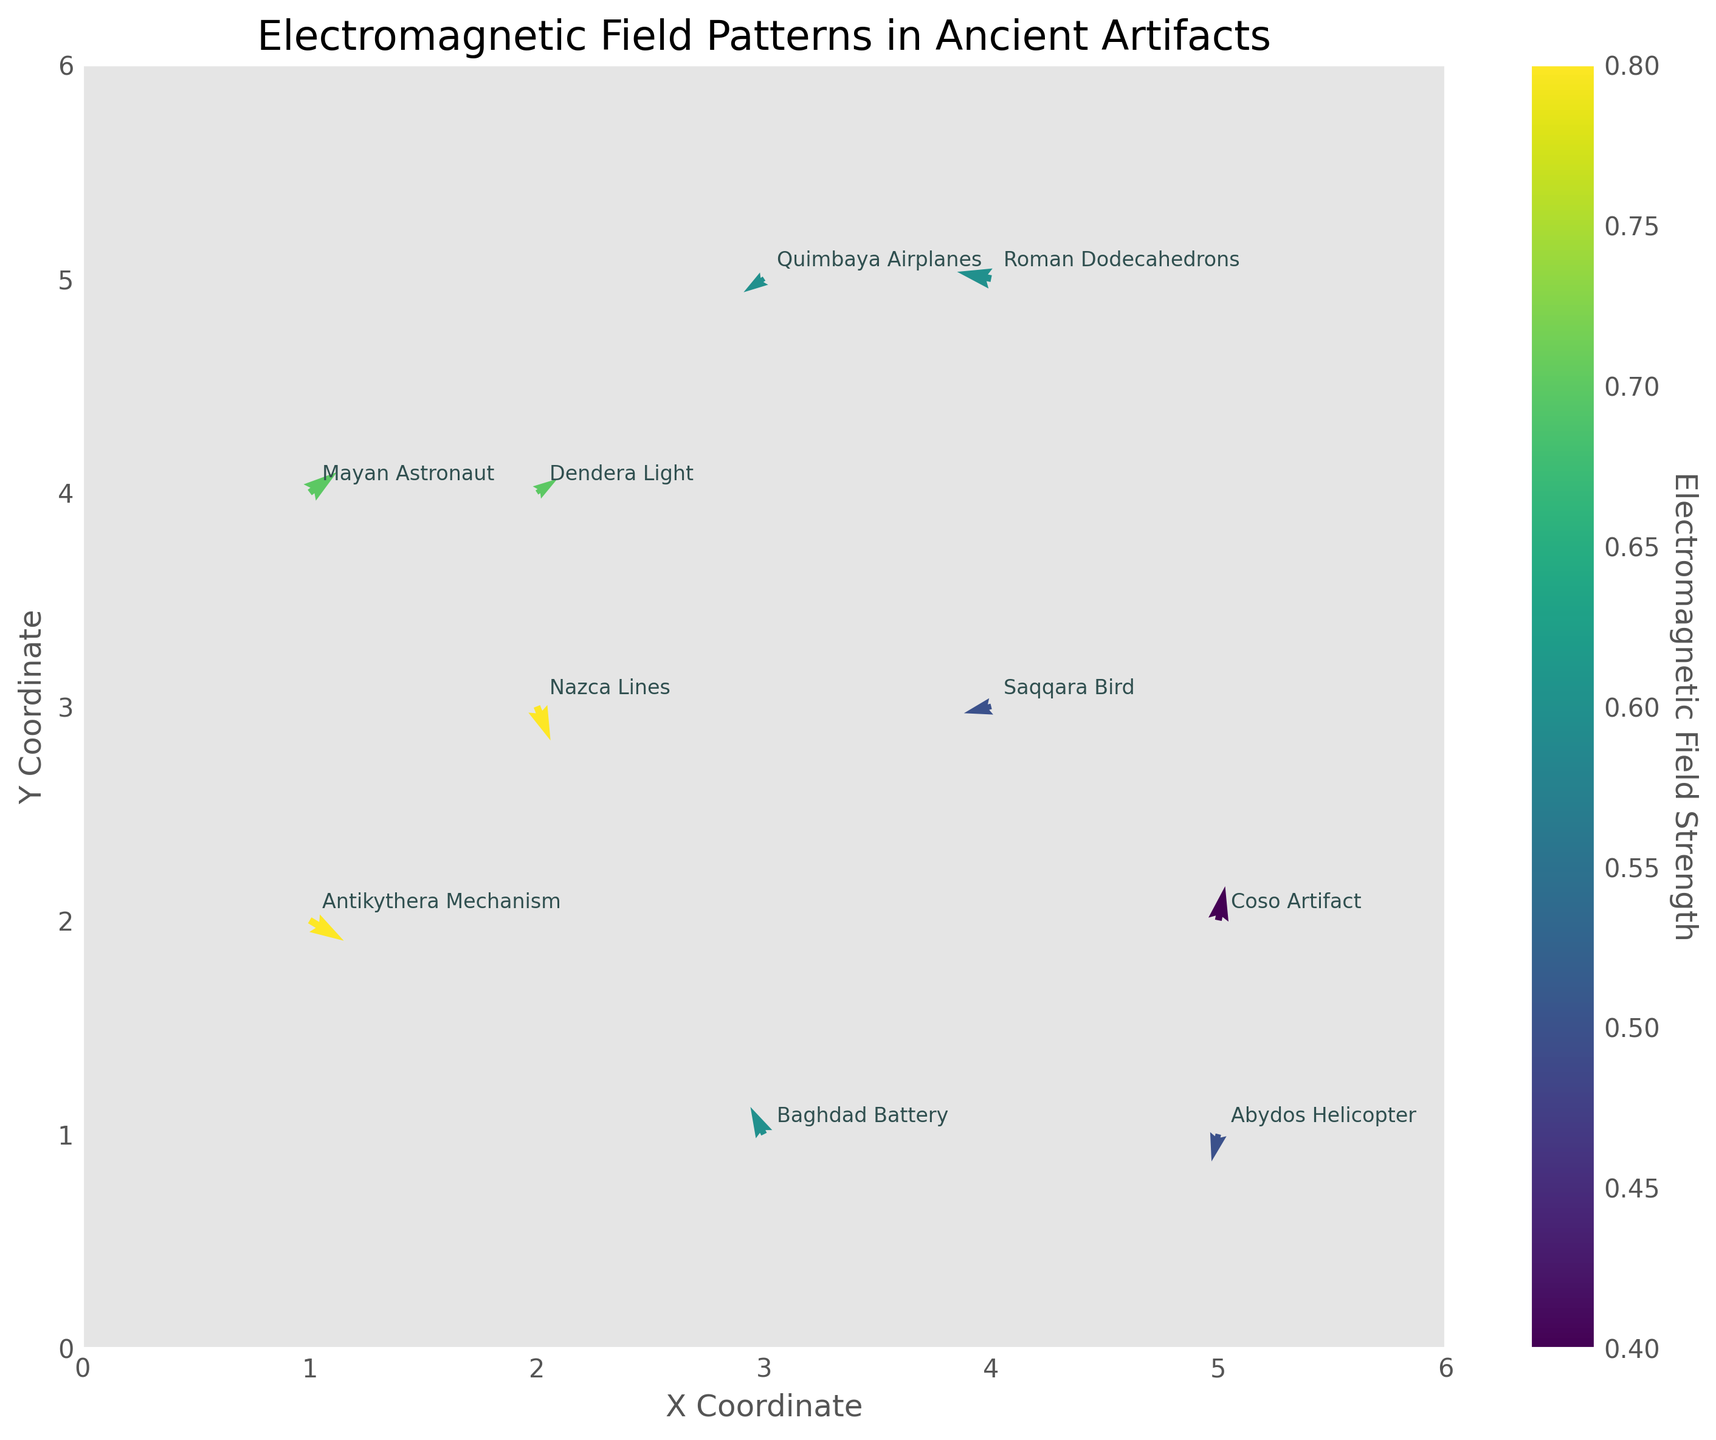What is the title of the plot? The title is displayed at the top of the plot and reads "Electromagnetic Field Patterns in Ancient Artifacts".
Answer: Electromagnetic Field Patterns in Ancient Artifacts How many different artifacts are represented in the figure? Each artifact has a label at its corresponding (x, y) coordinate. Counting these labels, we get a total of 10 artifacts.
Answer: 10 Which artifact is located at the highest y-coordinate? The y-coordinates are shown on the vertical axis. The artifact located at the highest position is the "Quimbaya Airplanes" at a y-coordinate of 5.
Answer: Quimbaya Airplanes Which direction is the electromagnetic field of the Antikythera Mechanism? The direction is indicated by the arrow originating from the (x, y) coordinate of 1,2. The arrow points downwards and to the right, corresponding to the vectors (u, v) = (0.5, -0.3).
Answer: Downwards and to the right What is the color representing the electromagnetic field strength of the Abydos Helicopter? The color varies according to the field strength and is displayed in a color gradient from the color bar. The Abydos Helicopter, with a strength of 0.5, corresponds to a medium greenish color from the color map.
Answer: Medium greenish Which artifact has the strongest electromagnetic field? The strength of the field is shown by color intensity. The Roman Dodecahedrons have the strongest field with a value of 0.8.
Answer: Roman Dodecahedrons What is the resulting direction of the field for the Saqqara Bird artifact? The arrow at the coordinates of the Saqqara Bird (4, 3) indicates the direction which is downwards and to the left, matching the vectors (u, v) = (-0.4, -0.1).
Answer: Downwards and to the left What is the average electromagnetic field strength of the artifacts depicted? Summing up the field strengths (0.8, 0.6, 0.7, 0.5, 0.4, 0.6, 0.7, 0.5, 0.8, 0.6) gives a total of 6.2. Dividing this by the number of artifacts (10) gives an average of 0.62.
Answer: 0.62 Which two artifacts have opposite directions in their electromagnetic vector fields? By observing the directions of the vectors, the artifact "Nazca Lines" with a direction downwards and to the left (0.2, -0.5) and "Coso Artifact" with a direction upwards and to the right (0.1, 0.5) have opposite directions.
Answer: Nazca Lines and Coso Artifact Which artifact has the closest electromagnetic field strength to 0.4? By comparing the strength values, the "Coso Artifact" has the closest strength to 0.4.
Answer: Coso Artifact 